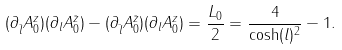Convert formula to latex. <formula><loc_0><loc_0><loc_500><loc_500>( \partial _ { \bar { l } } A _ { 0 } ^ { z } ) ( \partial _ { l } A _ { 0 } ^ { \bar { z } } ) - ( \partial _ { \bar { l } } A _ { 0 } ^ { \bar { z } } ) ( \partial _ { l } A _ { 0 } ^ { z } ) = \frac { L _ { 0 } } { 2 } = \frac { 4 } { \cosh ( l ) ^ { 2 } } - 1 .</formula> 